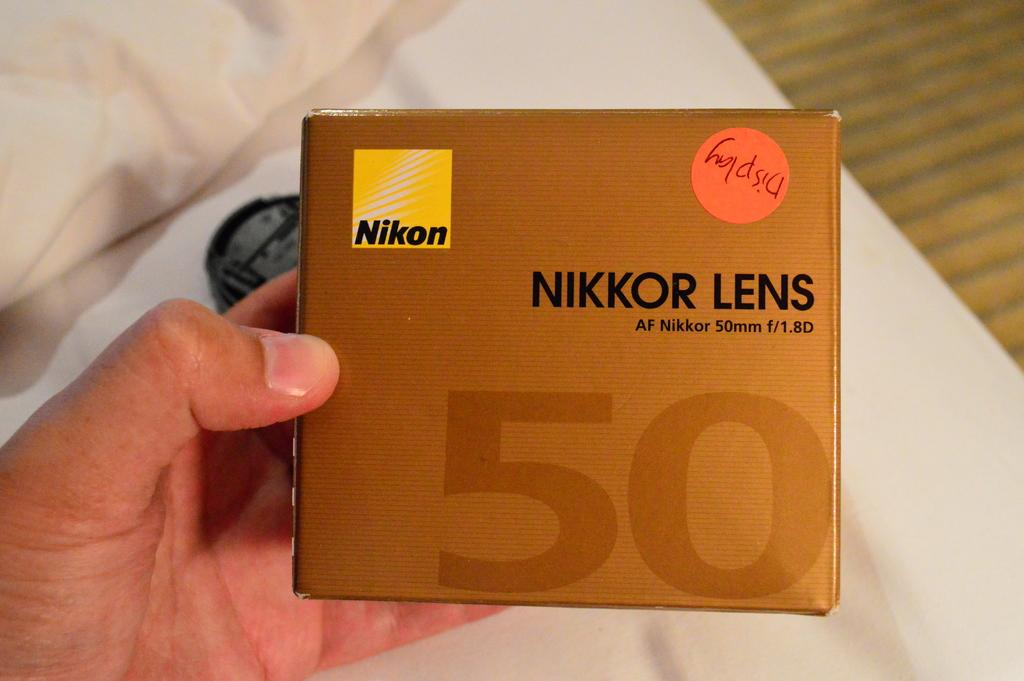<image>
Present a compact description of the photo's key features. A box of Nikkor Lens has a yellow Nikon logo on the front 